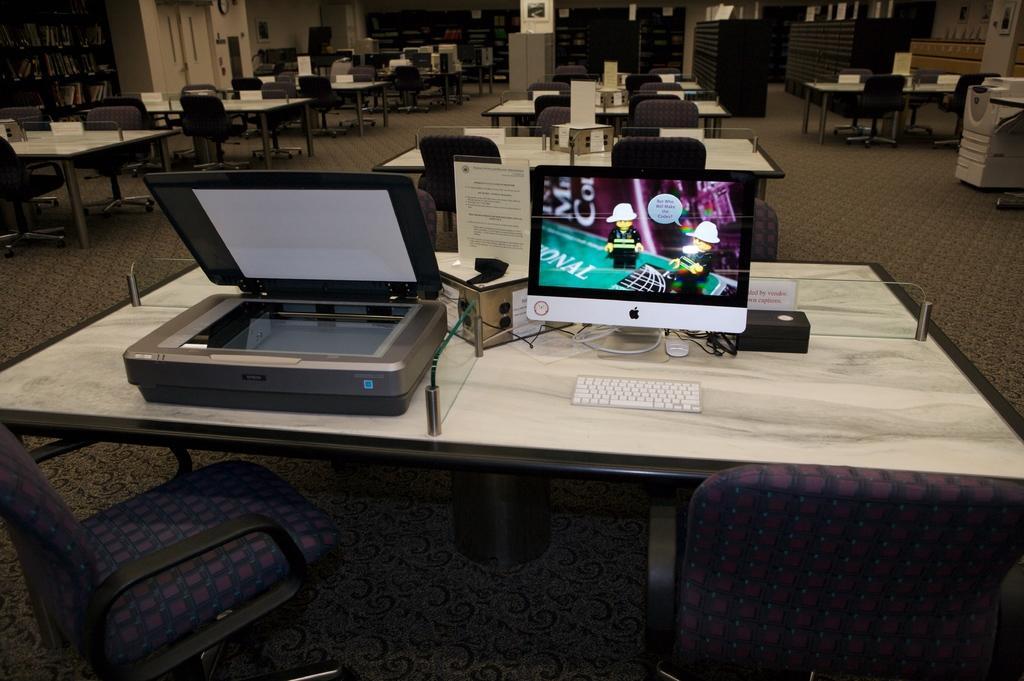Could you give a brief overview of what you see in this image? in this picture we see many tables and in front of them there are chairs and on this front table we have monitor, keyboard, printer present. Here we have xerox machine or photocopier machine. In the background we have shelves containing books. It looks like an office place or a library. 